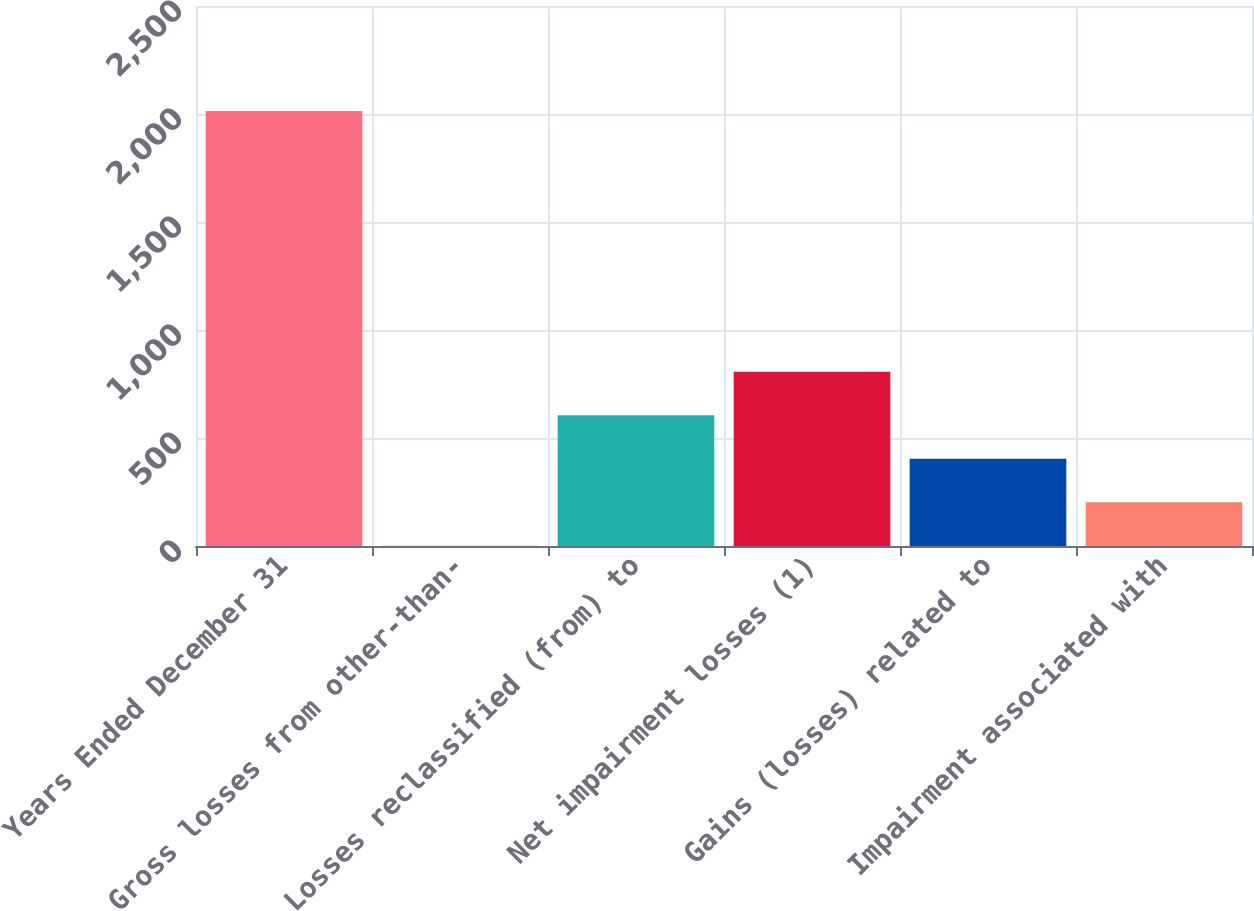<chart> <loc_0><loc_0><loc_500><loc_500><bar_chart><fcel>Years Ended December 31<fcel>Gross losses from other-than-<fcel>Losses reclassified (from) to<fcel>Net impairment losses (1)<fcel>Gains (losses) related to<fcel>Impairment associated with<nl><fcel>2014<fcel>1<fcel>604.9<fcel>806.2<fcel>403.6<fcel>202.3<nl></chart> 